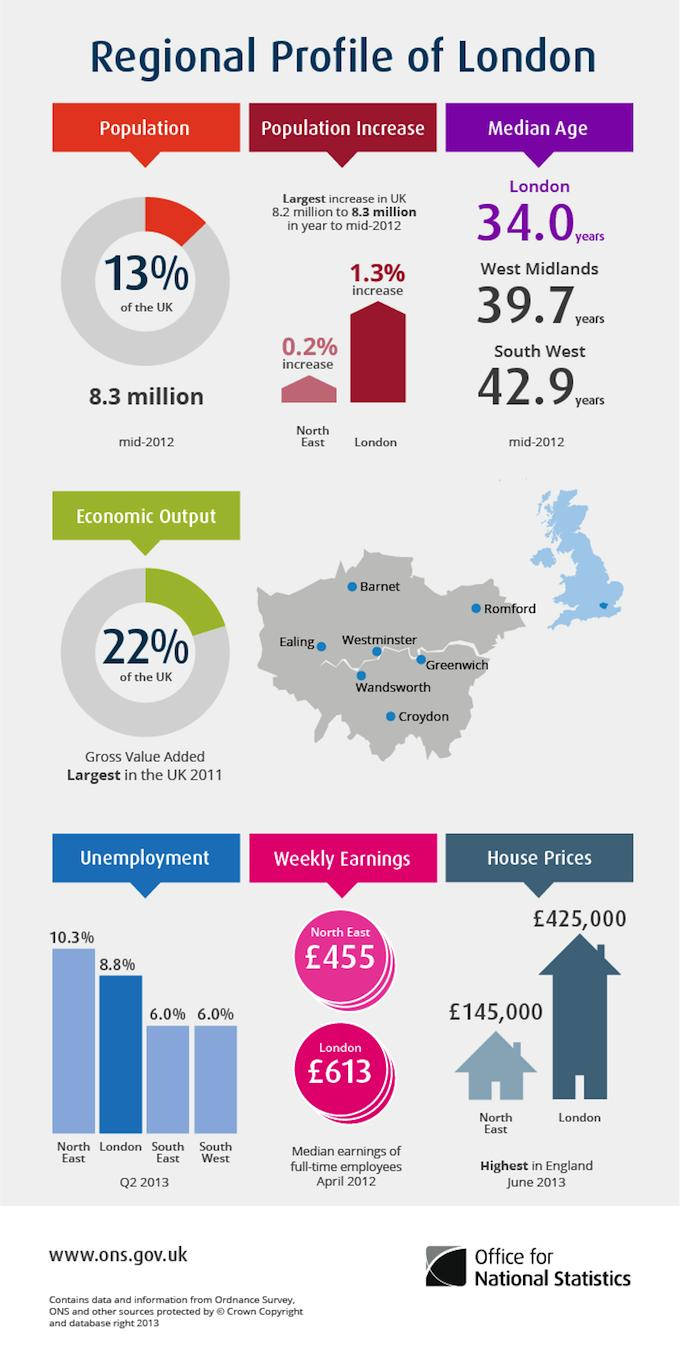Point out several critical features in this image. The unemployment rate in the North East of England is higher than in London by 1.5%. The South East and South West regions have an unemployment rate of 6% each. Four regions have been considered for unemployment statistics. In London, approximately 13% of the total UK population resides. The median age in London is higher than the difference of ages in the West Midlands. 